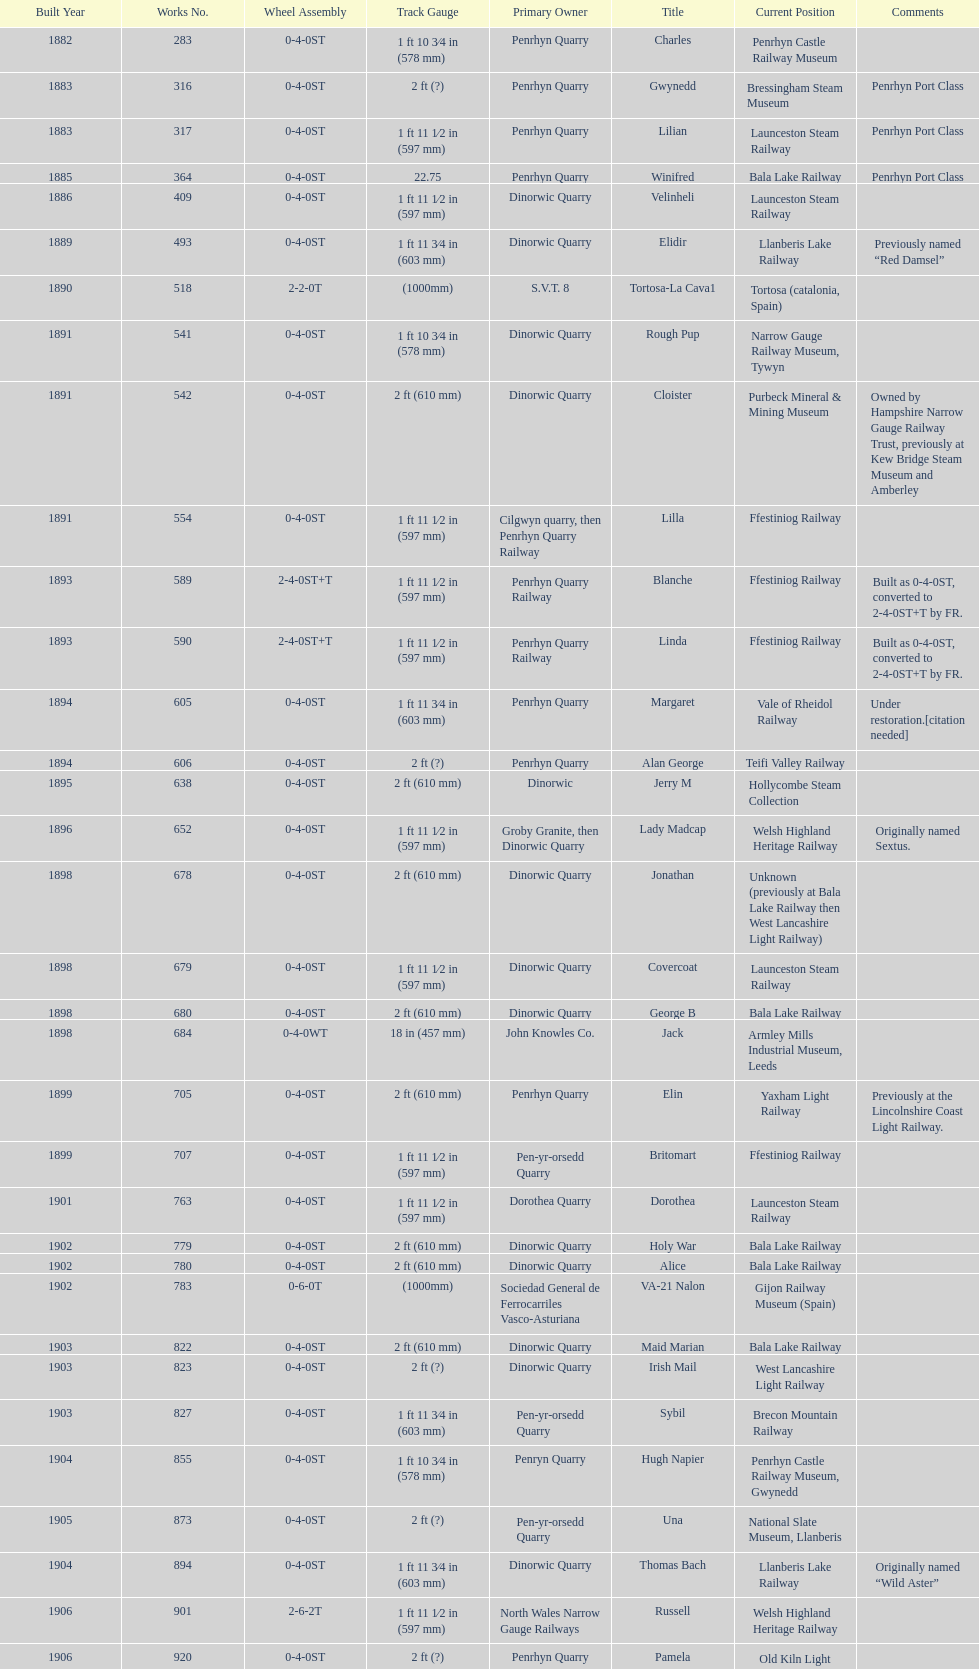What is the works number of the only item built in 1882? 283. 